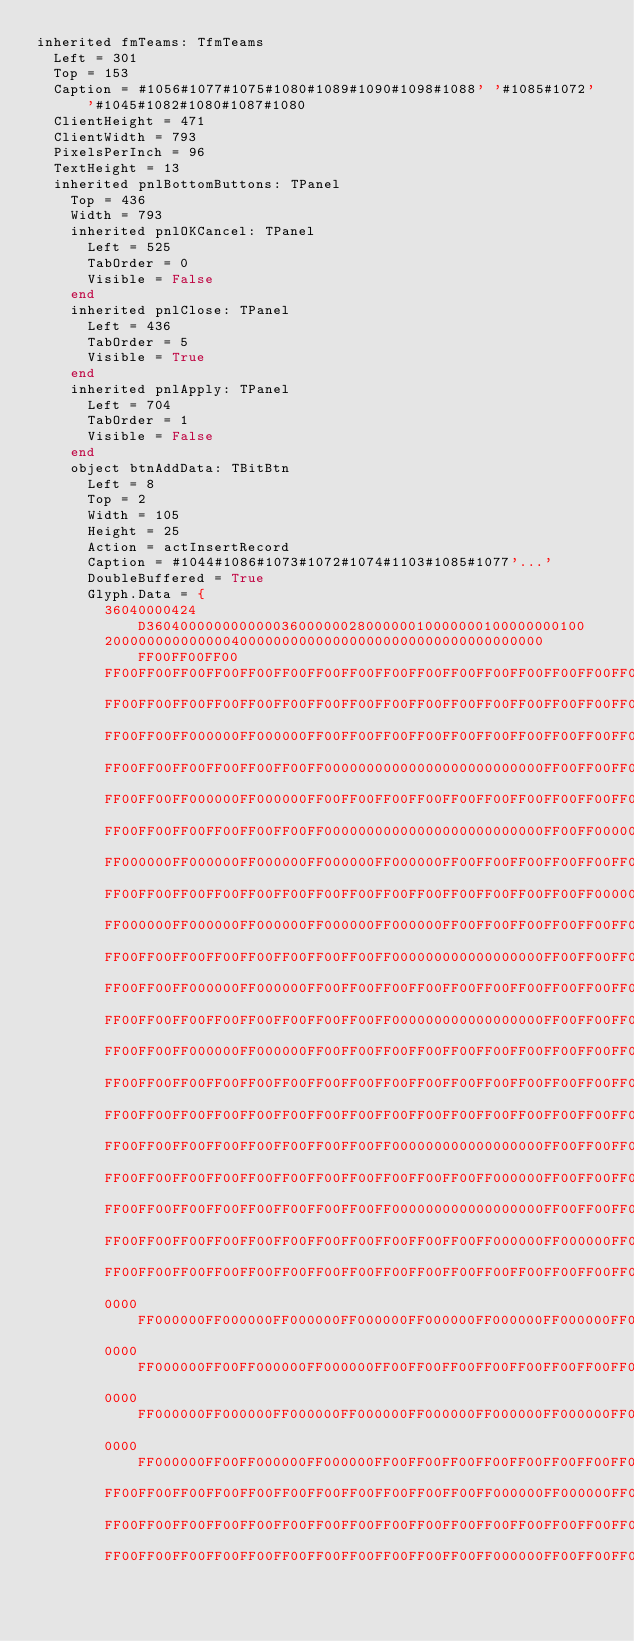<code> <loc_0><loc_0><loc_500><loc_500><_Pascal_>inherited fmTeams: TfmTeams
  Left = 301
  Top = 153
  Caption = #1056#1077#1075#1080#1089#1090#1098#1088' '#1085#1072' '#1045#1082#1080#1087#1080
  ClientHeight = 471
  ClientWidth = 793
  PixelsPerInch = 96
  TextHeight = 13
  inherited pnlBottomButtons: TPanel
    Top = 436
    Width = 793
    inherited pnlOKCancel: TPanel
      Left = 525
      TabOrder = 0
      Visible = False
    end
    inherited pnlClose: TPanel
      Left = 436
      TabOrder = 5
      Visible = True
    end
    inherited pnlApply: TPanel
      Left = 704
      TabOrder = 1
      Visible = False
    end
    object btnAddData: TBitBtn
      Left = 8
      Top = 2
      Width = 105
      Height = 25
      Action = actInsertRecord
      Caption = #1044#1086#1073#1072#1074#1103#1085#1077'...'
      DoubleBuffered = True
      Glyph.Data = {
        36040000424D3604000000000000360000002800000010000000100000000100
        2000000000000004000000000000000000000000000000000000FF00FF00FF00
        FF00FF00FF00FF00FF00FF00FF00FF00FF00FF00FF00FF00FF00FF00FF00FF00
        FF00FF00FF00FF00FF00FF00FF00FF00FF00FF00FF00FF00FF00FF00FF00FF00
        FF00FF00FF000000FF000000FF00FF00FF00FF00FF00FF00FF00FF00FF00FF00
        FF00FF00FF00FF00FF00FF00FF00000000000000000000000000FF00FF00FF00
        FF00FF00FF000000FF000000FF00FF00FF00FF00FF00FF00FF00FF00FF00FF00
        FF00FF00FF00FF00FF00FF00FF00000000000000000000000000FF00FF000000
        FF000000FF000000FF000000FF000000FF000000FF00FF00FF00FF00FF00FF00
        FF00FF00FF00FF00FF00FF00FF00FF00FF00FF00FF00FF00FF00FF00FF000000
        FF000000FF000000FF000000FF000000FF000000FF00FF00FF00FF00FF00FF00
        FF00FF00FF00FF00FF00FF00FF00FF00FF000000000000000000FF00FF00FF00
        FF00FF00FF000000FF000000FF00FF00FF00FF00FF00FF00FF00FF00FF00FF00
        FF00FF00FF00FF00FF00FF00FF00FF00FF000000000000000000FF00FF00FF00
        FF00FF00FF000000FF000000FF00FF00FF00FF00FF00FF00FF00FF00FF00FF00
        FF00FF00FF00FF00FF00FF00FF00FF00FF00FF00FF00FF00FF00FF00FF00FF00
        FF00FF00FF00FF00FF00FF00FF00FF00FF00FF00FF00FF00FF00FF00FF00FF00
        FF00FF00FF00FF00FF00FF00FF00FF00FF000000000000000000FF00FF00FF00
        FF00FF00FF00FF00FF00FF00FF00FF00FF00FF00FF00FF000000FF00FF00FF00
        FF00FF00FF00FF00FF00FF00FF00FF00FF000000000000000000FF00FF00FF00
        FF00FF00FF00FF00FF00FF00FF00FF00FF00FF00FF00FF000000FF000000FF00
        FF00FF00FF00FF00FF00FF00FF00FF00FF00FF00FF00FF00FF00FF00FF00FF00
        0000FF000000FF000000FF000000FF000000FF000000FF000000FF000000FF00
        0000FF000000FF00FF000000FF000000FF00FF00FF00FF00FF00FF00FF00FF00
        0000FF000000FF000000FF000000FF000000FF000000FF000000FF000000FF00
        0000FF000000FF00FF000000FF000000FF00FF00FF00FF00FF00FF00FF00FF00
        FF00FF00FF00FF00FF00FF00FF00FF00FF00FF00FF00FF000000FF000000FF00
        FF00FF00FF00FF00FF00FF00FF00FF00FF00FF00FF00FF00FF00FF00FF00FF00
        FF00FF00FF00FF00FF00FF00FF00FF00FF00FF00FF00FF000000FF00FF00FF00</code> 